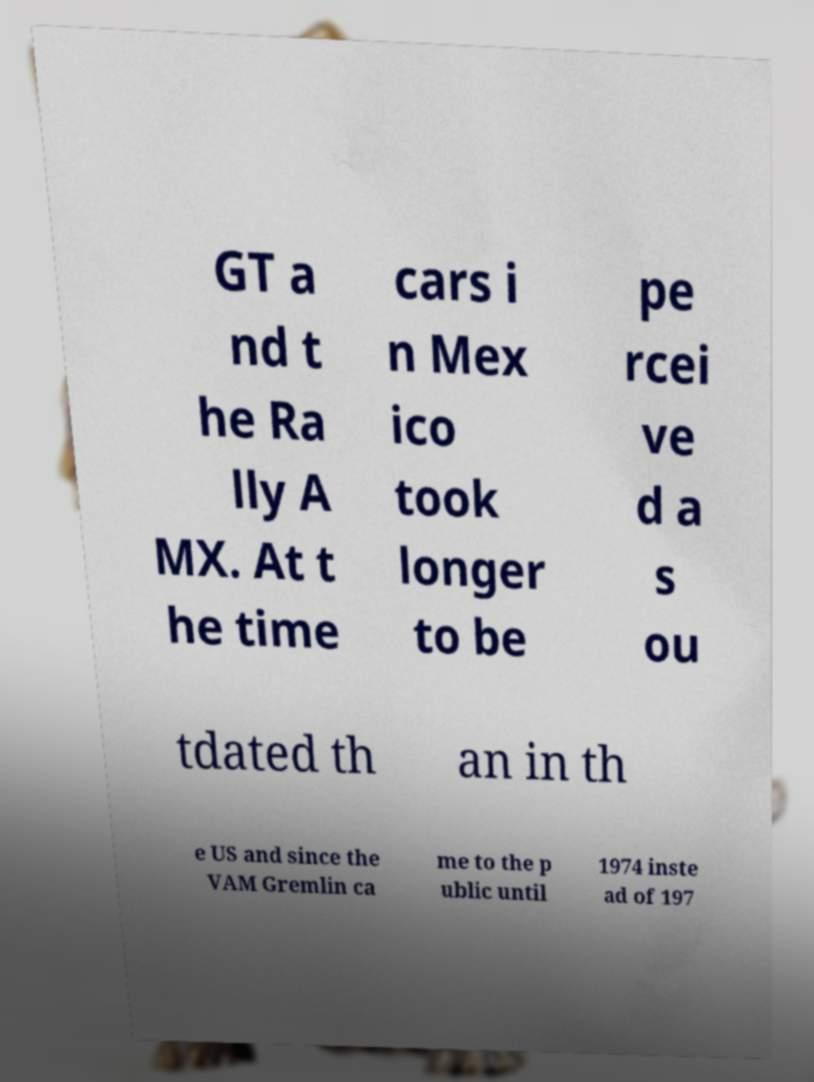There's text embedded in this image that I need extracted. Can you transcribe it verbatim? GT a nd t he Ra lly A MX. At t he time cars i n Mex ico took longer to be pe rcei ve d a s ou tdated th an in th e US and since the VAM Gremlin ca me to the p ublic until 1974 inste ad of 197 